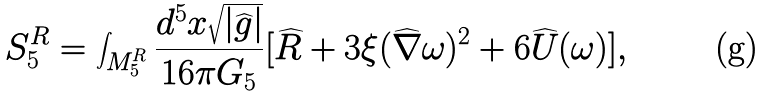<formula> <loc_0><loc_0><loc_500><loc_500>S _ { 5 } ^ { R } = \int _ { M _ { 5 } ^ { R } } \frac { d ^ { 5 } x \sqrt { | \widehat { g } | } } { 1 6 \pi G _ { 5 } } [ \widehat { R } + 3 \xi ( \widehat { \nabla } \omega ) ^ { 2 } + 6 \widehat { U } ( \omega ) ] ,</formula> 